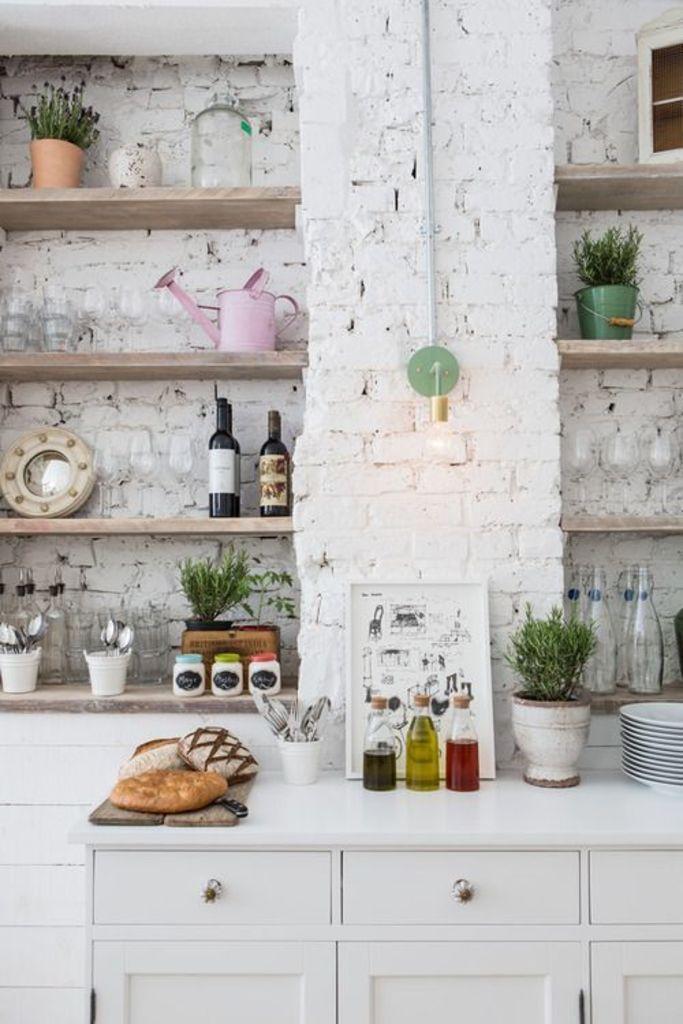Can you describe this image briefly? In this picture we can see a table on which a flower pot, plates, bottles and other things are kept. In the background, we can see a white brick wall with many rows and things kept in them. 